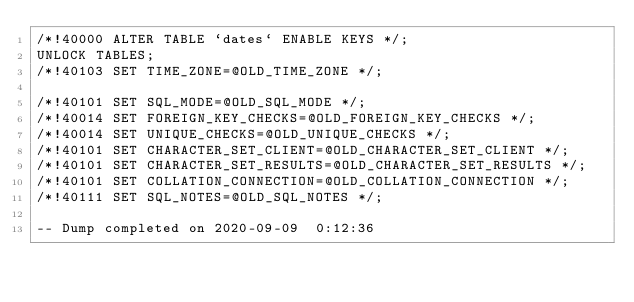Convert code to text. <code><loc_0><loc_0><loc_500><loc_500><_SQL_>/*!40000 ALTER TABLE `dates` ENABLE KEYS */;
UNLOCK TABLES;
/*!40103 SET TIME_ZONE=@OLD_TIME_ZONE */;

/*!40101 SET SQL_MODE=@OLD_SQL_MODE */;
/*!40014 SET FOREIGN_KEY_CHECKS=@OLD_FOREIGN_KEY_CHECKS */;
/*!40014 SET UNIQUE_CHECKS=@OLD_UNIQUE_CHECKS */;
/*!40101 SET CHARACTER_SET_CLIENT=@OLD_CHARACTER_SET_CLIENT */;
/*!40101 SET CHARACTER_SET_RESULTS=@OLD_CHARACTER_SET_RESULTS */;
/*!40101 SET COLLATION_CONNECTION=@OLD_COLLATION_CONNECTION */;
/*!40111 SET SQL_NOTES=@OLD_SQL_NOTES */;

-- Dump completed on 2020-09-09  0:12:36
</code> 